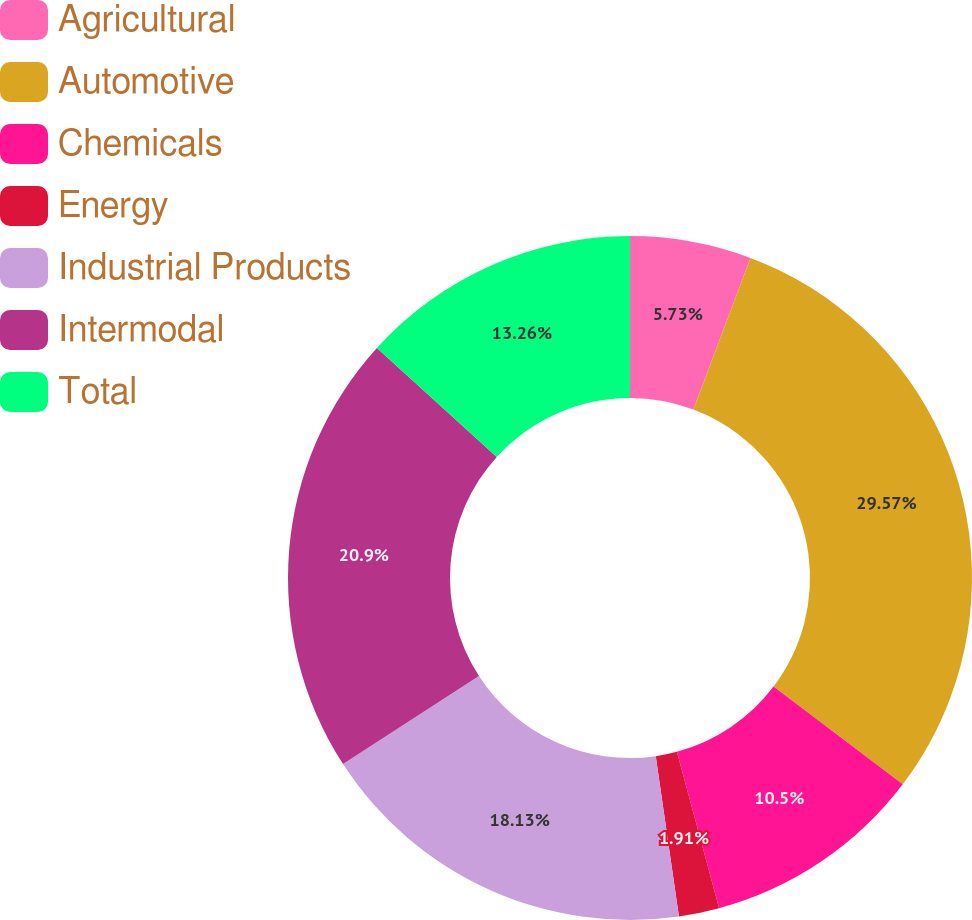<chart> <loc_0><loc_0><loc_500><loc_500><pie_chart><fcel>Agricultural<fcel>Automotive<fcel>Chemicals<fcel>Energy<fcel>Industrial Products<fcel>Intermodal<fcel>Total<nl><fcel>5.73%<fcel>29.58%<fcel>10.5%<fcel>1.91%<fcel>18.13%<fcel>20.9%<fcel>13.26%<nl></chart> 